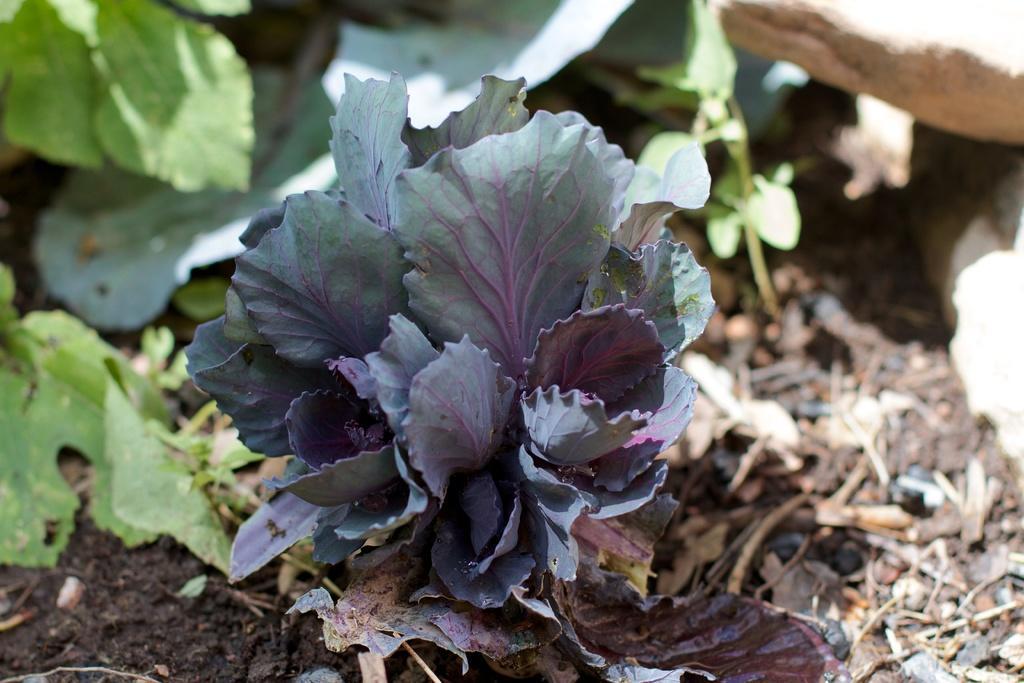Can you describe this image briefly? In this image we can see there are some plants, also we can see there are some stones and leaves on the ground. 